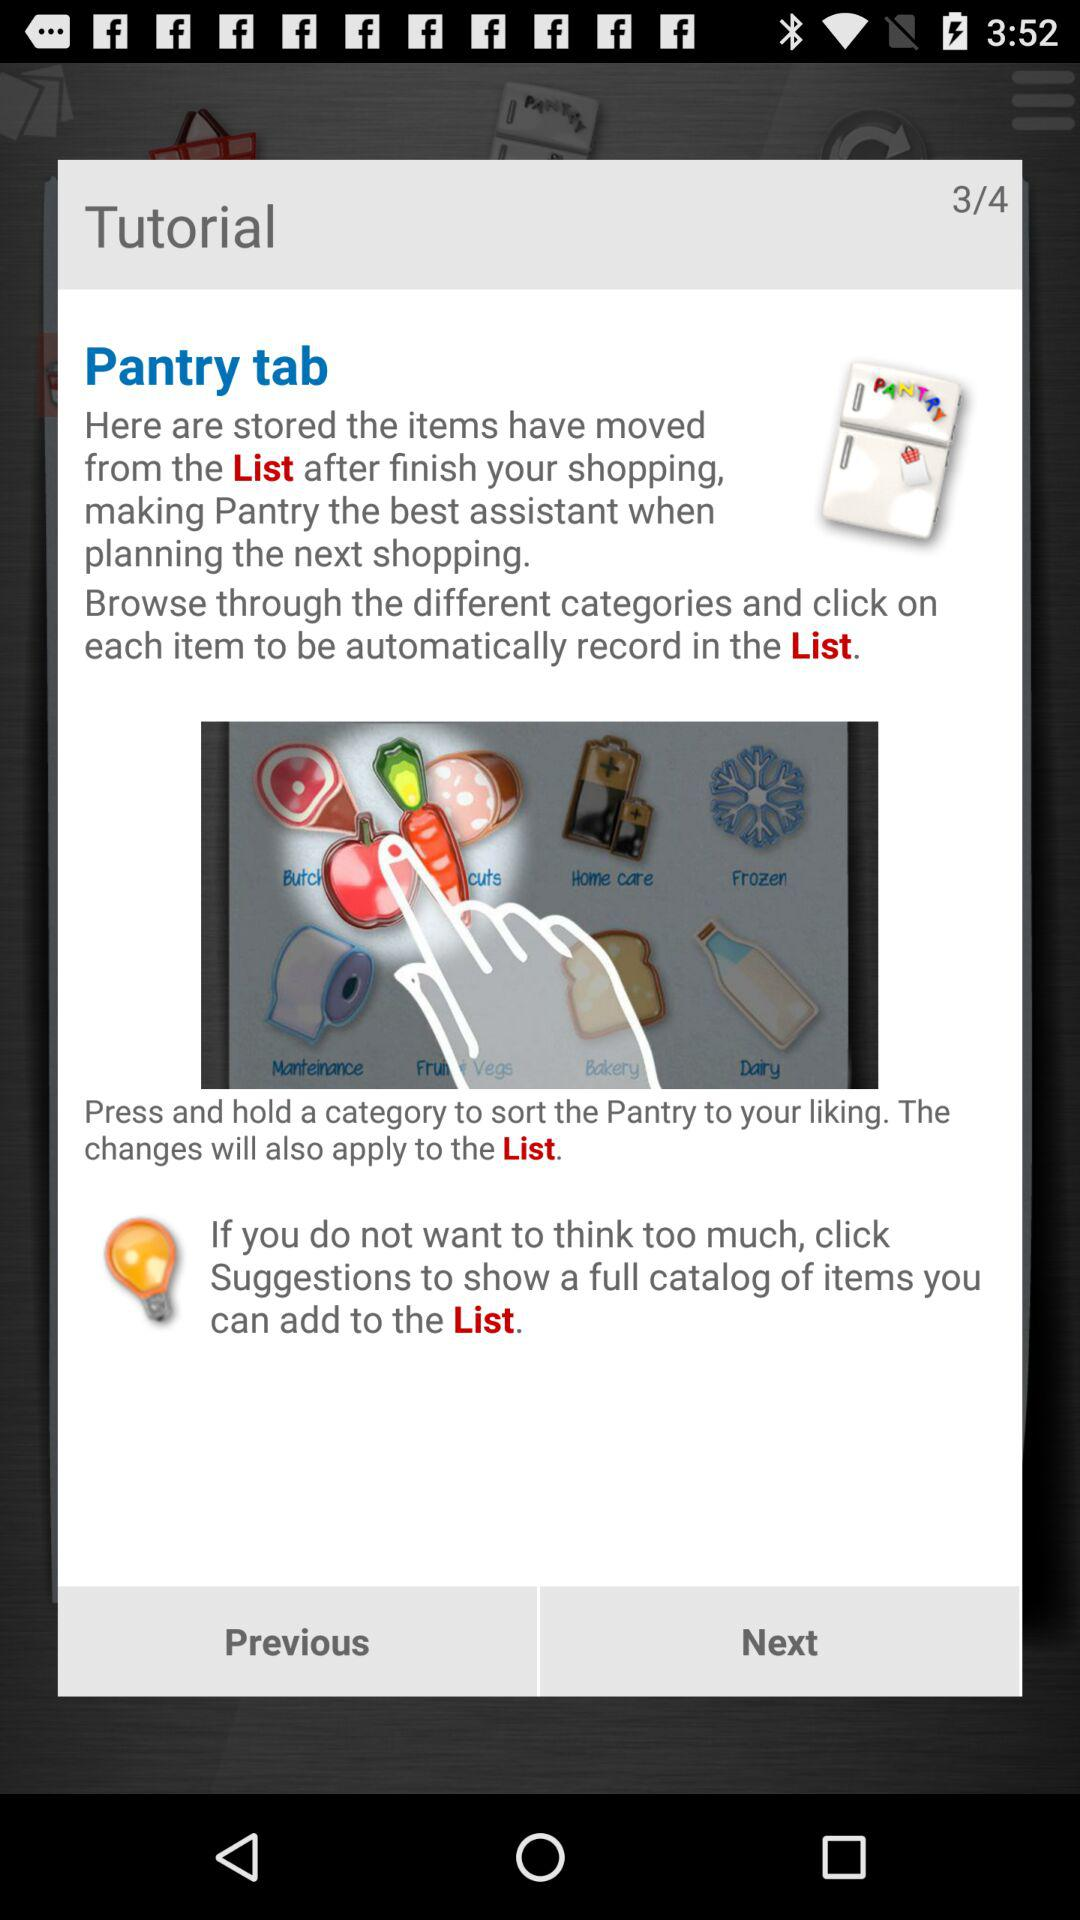What is the total number of pages in the tutorial? The total number of pages is 4. 